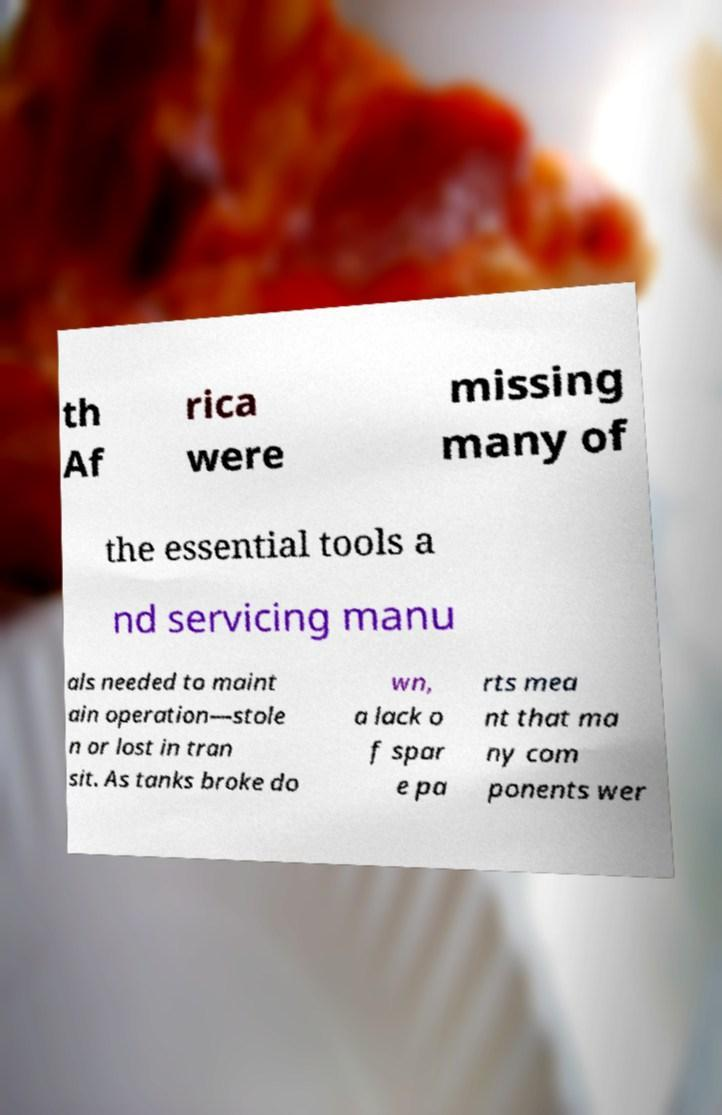Please identify and transcribe the text found in this image. th Af rica were missing many of the essential tools a nd servicing manu als needed to maint ain operation—stole n or lost in tran sit. As tanks broke do wn, a lack o f spar e pa rts mea nt that ma ny com ponents wer 